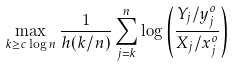Convert formula to latex. <formula><loc_0><loc_0><loc_500><loc_500>\max _ { k \geq c \log n } \frac { 1 } { h ( k / n ) } \sum _ { j = k } ^ { n } \log \left ( \frac { Y _ { j } / y _ { j } ^ { o } } { X _ { j } / x _ { j } ^ { o } } \right )</formula> 